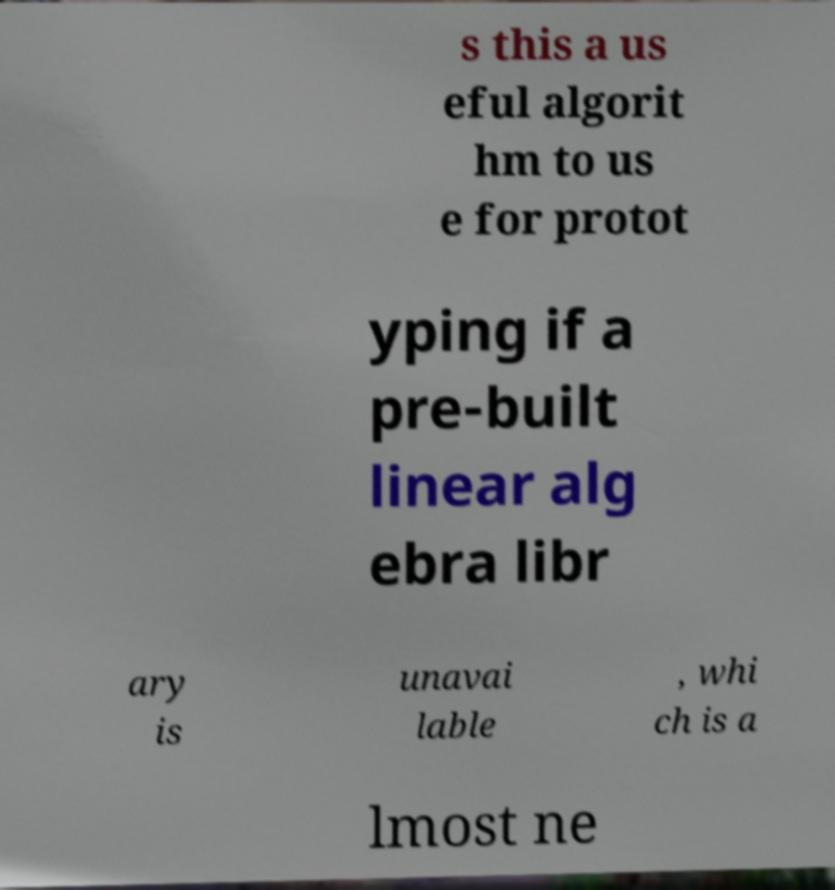I need the written content from this picture converted into text. Can you do that? s this a us eful algorit hm to us e for protot yping if a pre-built linear alg ebra libr ary is unavai lable , whi ch is a lmost ne 